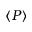<formula> <loc_0><loc_0><loc_500><loc_500>\left < P \right ></formula> 